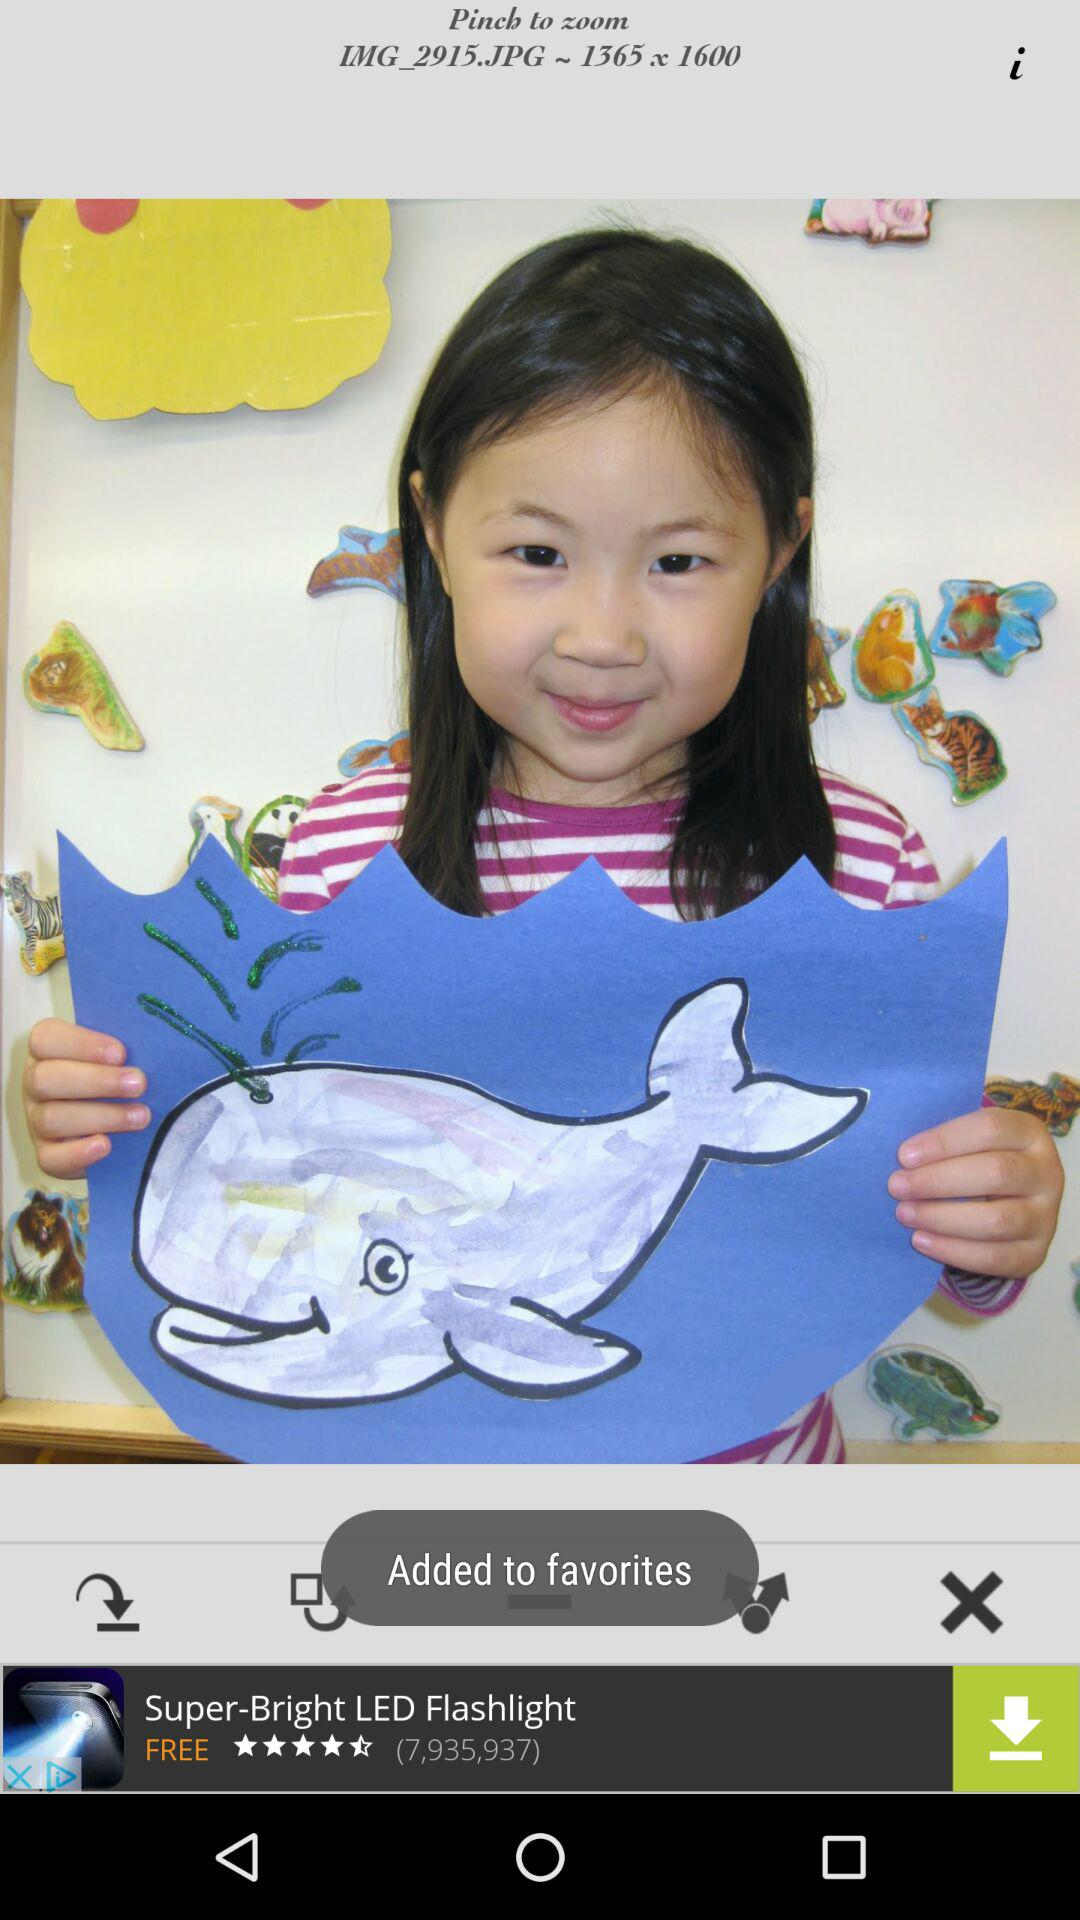What is the size of the image? The size of the image is 1365 x 1600. 